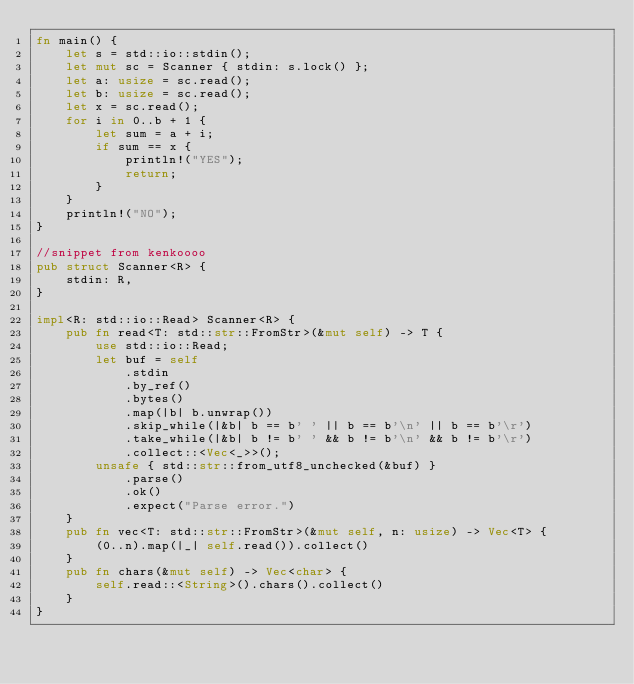<code> <loc_0><loc_0><loc_500><loc_500><_Rust_>fn main() {
    let s = std::io::stdin();
    let mut sc = Scanner { stdin: s.lock() };
    let a: usize = sc.read();
    let b: usize = sc.read();
    let x = sc.read();
    for i in 0..b + 1 {
        let sum = a + i;
        if sum == x {
            println!("YES");
            return;
        }
    }
    println!("NO");
}

//snippet from kenkoooo
pub struct Scanner<R> {
    stdin: R,
}

impl<R: std::io::Read> Scanner<R> {
    pub fn read<T: std::str::FromStr>(&mut self) -> T {
        use std::io::Read;
        let buf = self
            .stdin
            .by_ref()
            .bytes()
            .map(|b| b.unwrap())
            .skip_while(|&b| b == b' ' || b == b'\n' || b == b'\r')
            .take_while(|&b| b != b' ' && b != b'\n' && b != b'\r')
            .collect::<Vec<_>>();
        unsafe { std::str::from_utf8_unchecked(&buf) }
            .parse()
            .ok()
            .expect("Parse error.")
    }
    pub fn vec<T: std::str::FromStr>(&mut self, n: usize) -> Vec<T> {
        (0..n).map(|_| self.read()).collect()
    }
    pub fn chars(&mut self) -> Vec<char> {
        self.read::<String>().chars().collect()
    }
}
</code> 